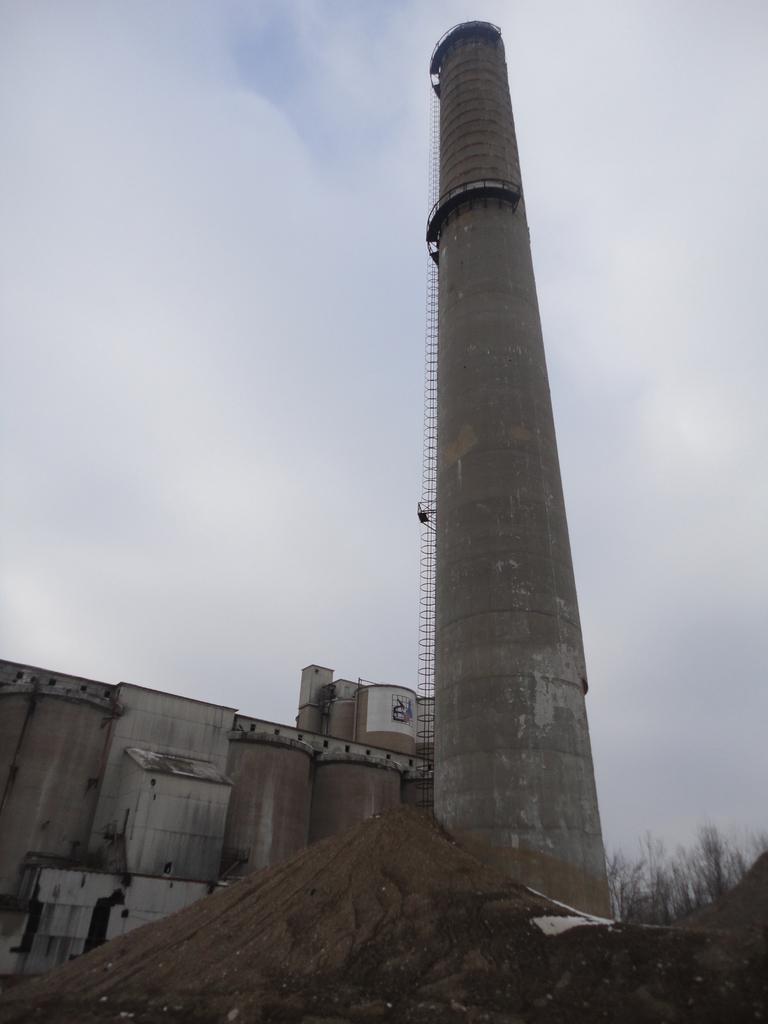Please provide a concise description of this image. In this image I can see a building, a chimney and few trees. In the front I can see sand and in the background I can see clouds and the sky. 